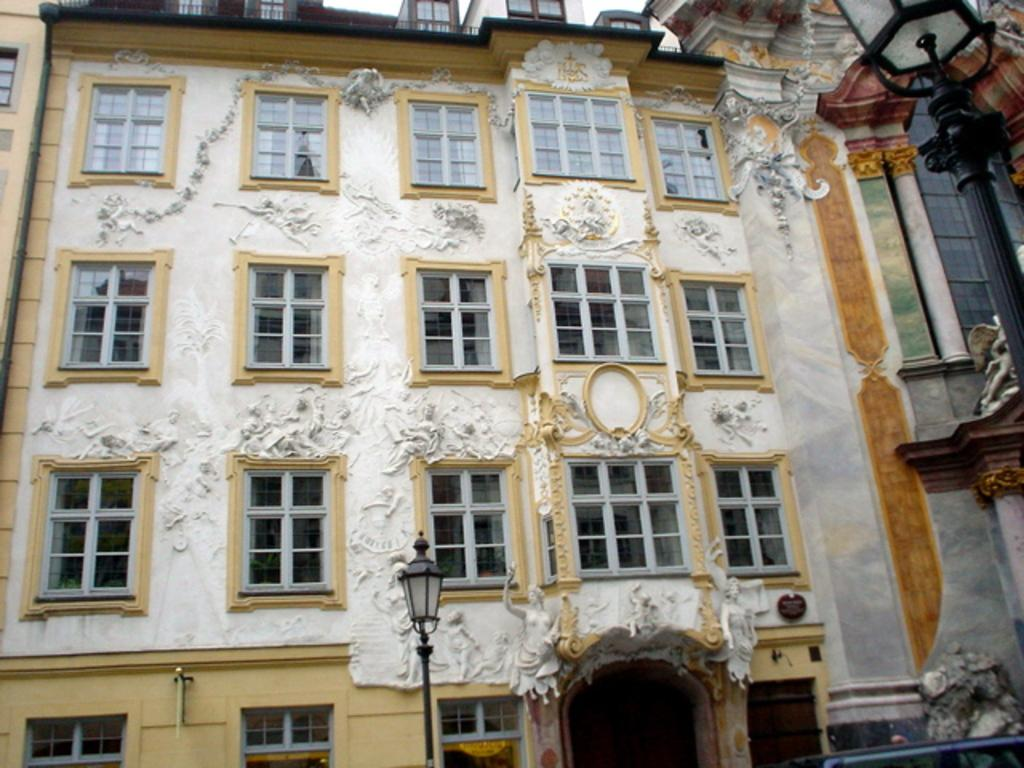What type of structures can be seen in the image? There are buildings in the image. What artistic elements are present in the image? There are sculptures in the image. What can be seen illuminating the scene in the image? There are lights in the image. What architectural features are visible in the image? There are pillars in the image. Can you describe any other objects present in the image? There are other objects in the image, but their specific details are not mentioned in the provided facts. What month is it in the image? The provided facts do not mention any specific month or time of year, so it cannot be determined from the image. How many sisters are present in the image? There are no people, let alone sisters, mentioned in the provided facts, so it cannot be determined from the image. 